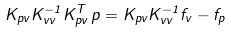<formula> <loc_0><loc_0><loc_500><loc_500>K _ { p v } K _ { v v } ^ { - 1 } K _ { p v } ^ { T } \, p = K _ { p v } K _ { v v } ^ { - 1 } f _ { v } - f _ { p }</formula> 